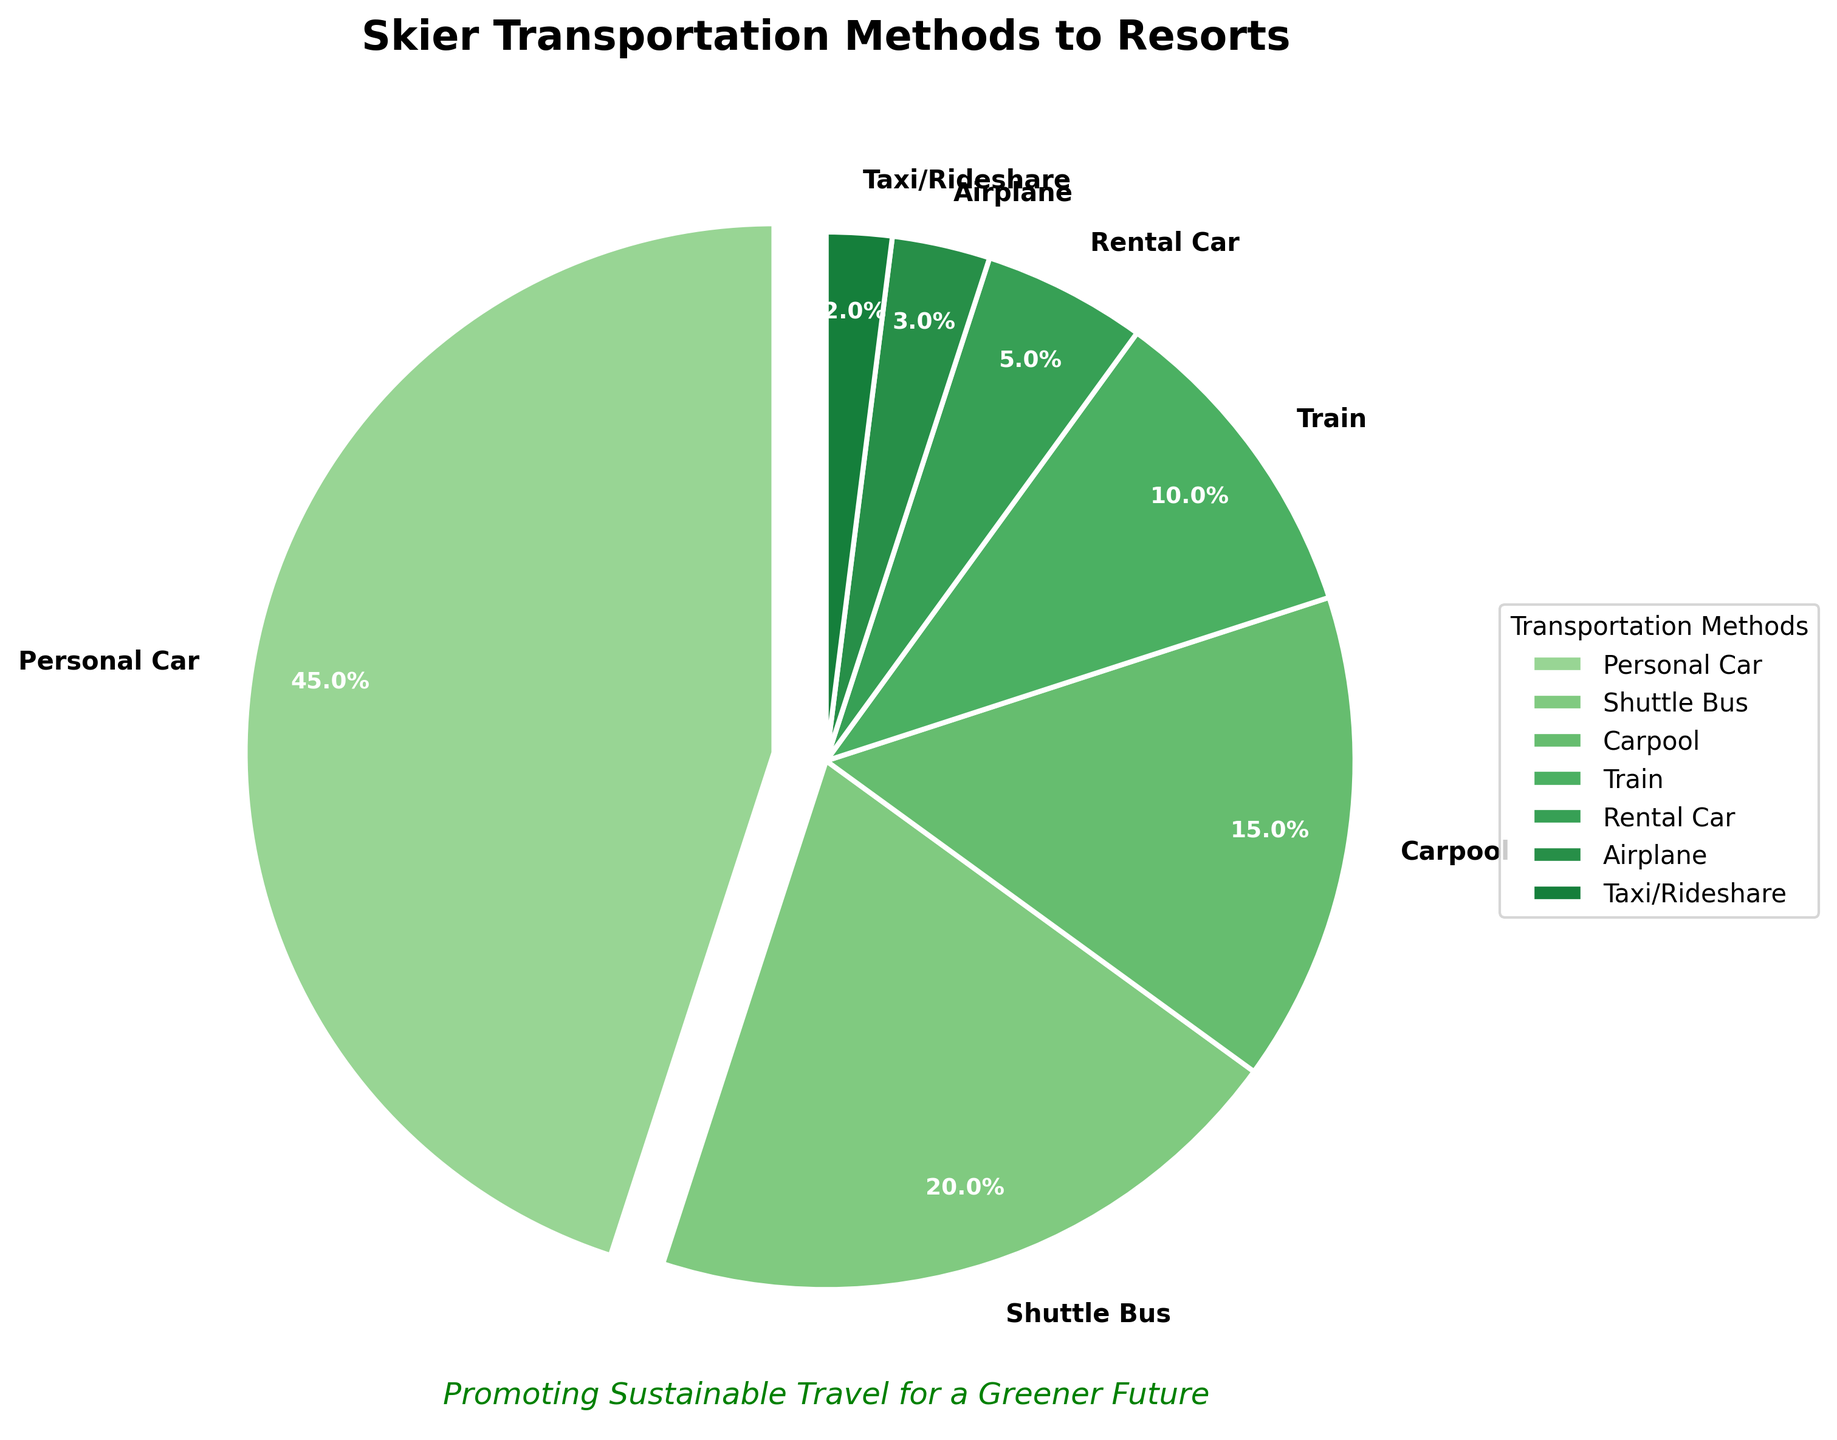What percentage of skiers travel to the resort by sustainable methods like Shuttle Bus, Carpool, and Train combined? First, identify the percentages for Shuttle Bus (20%), Carpool (15%), and Train (10%). Adding them together: 20% + 15% + 10% = 45%.
Answer: 45% Which transportation method is most frequently used by skiers, and what percentage does it represent? The largest section of the pie chart is for Personal Car, which represents 45%.
Answer: Personal Car, 45% How much greater is the percentage of skiers using Personal Car compared to those using the Shuttle Bus? The percentage for Personal Car is 45%, and for Shuttle Bus, it is 20%. Subtract the Shuttle Bus percentage from the Personal Car percentage: 45% - 20% = 25%.
Answer: 25% What is the total percentage of skiers using Rental Car, Airplane, and Taxi/Rideshare? Find and sum the percentages of Rental Car (5%), Airplane (3%), and Taxi/Rideshare (2%): 5% + 3% + 2% = 10%.
Answer: 10% Which transportation methods reflect the least-used options (less than 5% of skiers)? Identify the sections with percentages less than 5%. These are Airplane (3%) and Taxi/Rideshare (2%).
Answer: Airplane, Taxi/Rideshare Which transportation method is represented by the color closest to the darkest green shade in the pie chart? The darkest green shade typically highlights the most frequent method. Here, it corresponds to Personal Car, which stands out in the pie chart.
Answer: Personal Car Estimate the average percentage use of transportation methods, excluding the most frequently used one. Exclude Personal Car (45%). The remaining percentages are: 20% (Shuttle Bus) + 15% (Carpool) + 10% (Train) + 5% (Rental Car) + 3% (Airplane) + 2% (Taxi/Rideshare). Sum these values: 20% + 15% + 10% + 5% + 3% + 2% = 55%. There are 6 methods left, so the average is 55% / 6 ≈ 9.17%.
Answer: 9.17% 